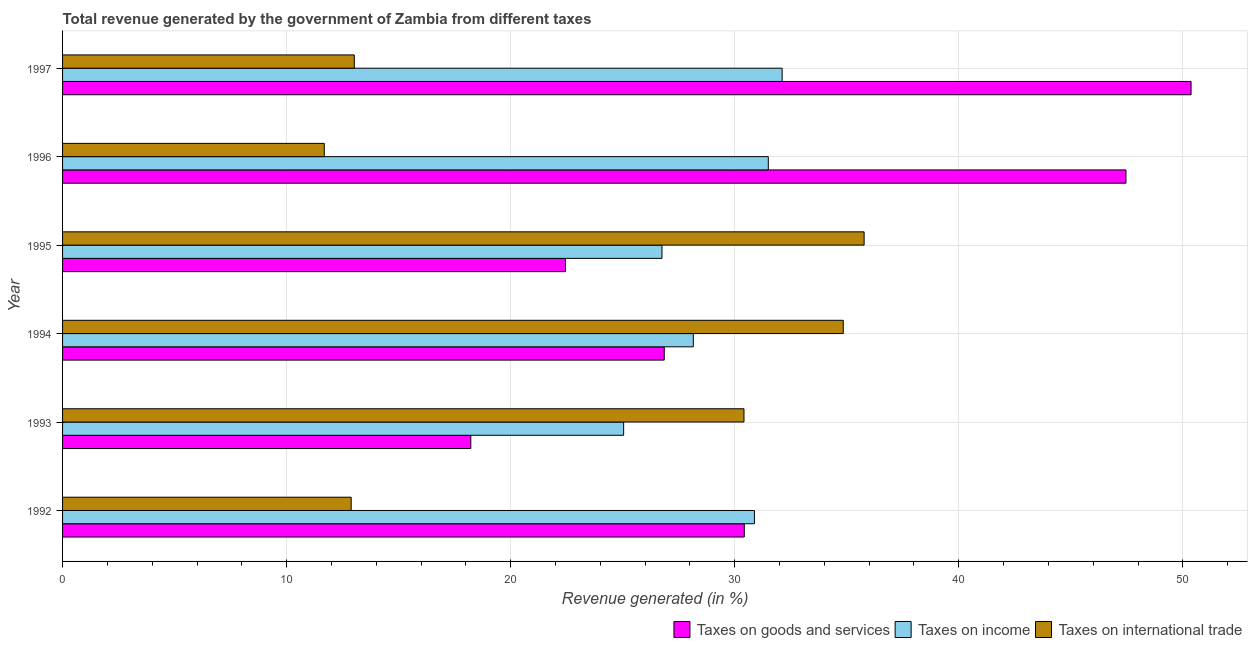In how many cases, is the number of bars for a given year not equal to the number of legend labels?
Your response must be concise. 0. What is the percentage of revenue generated by taxes on income in 1992?
Ensure brevity in your answer.  30.88. Across all years, what is the maximum percentage of revenue generated by taxes on income?
Give a very brief answer. 32.12. Across all years, what is the minimum percentage of revenue generated by taxes on income?
Ensure brevity in your answer.  25.04. In which year was the percentage of revenue generated by tax on international trade maximum?
Your answer should be very brief. 1995. In which year was the percentage of revenue generated by taxes on goods and services minimum?
Keep it short and to the point. 1993. What is the total percentage of revenue generated by taxes on income in the graph?
Provide a short and direct response. 174.44. What is the difference between the percentage of revenue generated by tax on international trade in 1992 and that in 1996?
Provide a short and direct response. 1.2. What is the difference between the percentage of revenue generated by taxes on goods and services in 1992 and the percentage of revenue generated by taxes on income in 1997?
Provide a short and direct response. -1.69. What is the average percentage of revenue generated by taxes on goods and services per year?
Your answer should be compact. 32.63. In the year 1992, what is the difference between the percentage of revenue generated by taxes on income and percentage of revenue generated by taxes on goods and services?
Offer a very short reply. 0.45. What is the ratio of the percentage of revenue generated by tax on international trade in 1993 to that in 1997?
Your response must be concise. 2.34. Is the difference between the percentage of revenue generated by taxes on income in 1994 and 1995 greater than the difference between the percentage of revenue generated by tax on international trade in 1994 and 1995?
Provide a succinct answer. Yes. What is the difference between the highest and the second highest percentage of revenue generated by taxes on goods and services?
Give a very brief answer. 2.9. What is the difference between the highest and the lowest percentage of revenue generated by tax on international trade?
Make the answer very short. 24.09. Is the sum of the percentage of revenue generated by tax on international trade in 1993 and 1997 greater than the maximum percentage of revenue generated by taxes on income across all years?
Provide a short and direct response. Yes. What does the 1st bar from the top in 1996 represents?
Make the answer very short. Taxes on international trade. What does the 3rd bar from the bottom in 1994 represents?
Make the answer very short. Taxes on international trade. Is it the case that in every year, the sum of the percentage of revenue generated by taxes on goods and services and percentage of revenue generated by taxes on income is greater than the percentage of revenue generated by tax on international trade?
Offer a terse response. Yes. Are all the bars in the graph horizontal?
Provide a short and direct response. Yes. What is the difference between two consecutive major ticks on the X-axis?
Your answer should be compact. 10. Are the values on the major ticks of X-axis written in scientific E-notation?
Offer a terse response. No. Does the graph contain grids?
Your response must be concise. Yes. Where does the legend appear in the graph?
Offer a very short reply. Bottom right. How are the legend labels stacked?
Provide a succinct answer. Horizontal. What is the title of the graph?
Offer a very short reply. Total revenue generated by the government of Zambia from different taxes. What is the label or title of the X-axis?
Make the answer very short. Revenue generated (in %). What is the Revenue generated (in %) of Taxes on goods and services in 1992?
Keep it short and to the point. 30.43. What is the Revenue generated (in %) of Taxes on income in 1992?
Your answer should be very brief. 30.88. What is the Revenue generated (in %) in Taxes on international trade in 1992?
Your answer should be compact. 12.88. What is the Revenue generated (in %) in Taxes on goods and services in 1993?
Offer a very short reply. 18.22. What is the Revenue generated (in %) of Taxes on income in 1993?
Provide a short and direct response. 25.04. What is the Revenue generated (in %) in Taxes on international trade in 1993?
Provide a succinct answer. 30.41. What is the Revenue generated (in %) in Taxes on goods and services in 1994?
Keep it short and to the point. 26.86. What is the Revenue generated (in %) in Taxes on income in 1994?
Offer a very short reply. 28.15. What is the Revenue generated (in %) in Taxes on international trade in 1994?
Your answer should be compact. 34.84. What is the Revenue generated (in %) of Taxes on goods and services in 1995?
Your response must be concise. 22.45. What is the Revenue generated (in %) of Taxes on income in 1995?
Offer a very short reply. 26.75. What is the Revenue generated (in %) in Taxes on international trade in 1995?
Your answer should be very brief. 35.78. What is the Revenue generated (in %) in Taxes on goods and services in 1996?
Your answer should be very brief. 47.46. What is the Revenue generated (in %) of Taxes on income in 1996?
Offer a terse response. 31.5. What is the Revenue generated (in %) in Taxes on international trade in 1996?
Offer a very short reply. 11.68. What is the Revenue generated (in %) in Taxes on goods and services in 1997?
Give a very brief answer. 50.37. What is the Revenue generated (in %) in Taxes on income in 1997?
Your response must be concise. 32.12. What is the Revenue generated (in %) in Taxes on international trade in 1997?
Your answer should be very brief. 13.02. Across all years, what is the maximum Revenue generated (in %) in Taxes on goods and services?
Your response must be concise. 50.37. Across all years, what is the maximum Revenue generated (in %) of Taxes on income?
Offer a very short reply. 32.12. Across all years, what is the maximum Revenue generated (in %) of Taxes on international trade?
Offer a terse response. 35.78. Across all years, what is the minimum Revenue generated (in %) of Taxes on goods and services?
Your response must be concise. 18.22. Across all years, what is the minimum Revenue generated (in %) of Taxes on income?
Ensure brevity in your answer.  25.04. Across all years, what is the minimum Revenue generated (in %) in Taxes on international trade?
Ensure brevity in your answer.  11.68. What is the total Revenue generated (in %) in Taxes on goods and services in the graph?
Offer a very short reply. 195.78. What is the total Revenue generated (in %) of Taxes on income in the graph?
Offer a terse response. 174.44. What is the total Revenue generated (in %) in Taxes on international trade in the graph?
Your response must be concise. 138.62. What is the difference between the Revenue generated (in %) in Taxes on goods and services in 1992 and that in 1993?
Keep it short and to the point. 12.21. What is the difference between the Revenue generated (in %) of Taxes on income in 1992 and that in 1993?
Keep it short and to the point. 5.84. What is the difference between the Revenue generated (in %) of Taxes on international trade in 1992 and that in 1993?
Your answer should be compact. -17.53. What is the difference between the Revenue generated (in %) of Taxes on goods and services in 1992 and that in 1994?
Your answer should be compact. 3.57. What is the difference between the Revenue generated (in %) of Taxes on income in 1992 and that in 1994?
Make the answer very short. 2.73. What is the difference between the Revenue generated (in %) in Taxes on international trade in 1992 and that in 1994?
Your response must be concise. -21.96. What is the difference between the Revenue generated (in %) in Taxes on goods and services in 1992 and that in 1995?
Offer a terse response. 7.98. What is the difference between the Revenue generated (in %) of Taxes on income in 1992 and that in 1995?
Ensure brevity in your answer.  4.13. What is the difference between the Revenue generated (in %) of Taxes on international trade in 1992 and that in 1995?
Your answer should be very brief. -22.89. What is the difference between the Revenue generated (in %) of Taxes on goods and services in 1992 and that in 1996?
Offer a very short reply. -17.04. What is the difference between the Revenue generated (in %) in Taxes on income in 1992 and that in 1996?
Your answer should be very brief. -0.62. What is the difference between the Revenue generated (in %) in Taxes on international trade in 1992 and that in 1996?
Offer a very short reply. 1.2. What is the difference between the Revenue generated (in %) of Taxes on goods and services in 1992 and that in 1997?
Give a very brief answer. -19.94. What is the difference between the Revenue generated (in %) of Taxes on income in 1992 and that in 1997?
Provide a short and direct response. -1.24. What is the difference between the Revenue generated (in %) of Taxes on international trade in 1992 and that in 1997?
Your answer should be compact. -0.14. What is the difference between the Revenue generated (in %) in Taxes on goods and services in 1993 and that in 1994?
Your response must be concise. -8.63. What is the difference between the Revenue generated (in %) in Taxes on income in 1993 and that in 1994?
Your response must be concise. -3.11. What is the difference between the Revenue generated (in %) of Taxes on international trade in 1993 and that in 1994?
Your answer should be compact. -4.43. What is the difference between the Revenue generated (in %) in Taxes on goods and services in 1993 and that in 1995?
Keep it short and to the point. -4.23. What is the difference between the Revenue generated (in %) of Taxes on income in 1993 and that in 1995?
Offer a terse response. -1.71. What is the difference between the Revenue generated (in %) of Taxes on international trade in 1993 and that in 1995?
Provide a short and direct response. -5.36. What is the difference between the Revenue generated (in %) in Taxes on goods and services in 1993 and that in 1996?
Provide a short and direct response. -29.24. What is the difference between the Revenue generated (in %) of Taxes on income in 1993 and that in 1996?
Make the answer very short. -6.46. What is the difference between the Revenue generated (in %) in Taxes on international trade in 1993 and that in 1996?
Your response must be concise. 18.73. What is the difference between the Revenue generated (in %) in Taxes on goods and services in 1993 and that in 1997?
Your response must be concise. -32.15. What is the difference between the Revenue generated (in %) in Taxes on income in 1993 and that in 1997?
Give a very brief answer. -7.07. What is the difference between the Revenue generated (in %) in Taxes on international trade in 1993 and that in 1997?
Give a very brief answer. 17.39. What is the difference between the Revenue generated (in %) of Taxes on goods and services in 1994 and that in 1995?
Keep it short and to the point. 4.41. What is the difference between the Revenue generated (in %) in Taxes on income in 1994 and that in 1995?
Offer a very short reply. 1.4. What is the difference between the Revenue generated (in %) of Taxes on international trade in 1994 and that in 1995?
Give a very brief answer. -0.93. What is the difference between the Revenue generated (in %) in Taxes on goods and services in 1994 and that in 1996?
Your answer should be compact. -20.61. What is the difference between the Revenue generated (in %) of Taxes on income in 1994 and that in 1996?
Offer a very short reply. -3.35. What is the difference between the Revenue generated (in %) in Taxes on international trade in 1994 and that in 1996?
Your answer should be very brief. 23.16. What is the difference between the Revenue generated (in %) of Taxes on goods and services in 1994 and that in 1997?
Provide a short and direct response. -23.51. What is the difference between the Revenue generated (in %) of Taxes on income in 1994 and that in 1997?
Make the answer very short. -3.96. What is the difference between the Revenue generated (in %) of Taxes on international trade in 1994 and that in 1997?
Provide a succinct answer. 21.82. What is the difference between the Revenue generated (in %) in Taxes on goods and services in 1995 and that in 1996?
Offer a very short reply. -25.01. What is the difference between the Revenue generated (in %) in Taxes on income in 1995 and that in 1996?
Offer a terse response. -4.75. What is the difference between the Revenue generated (in %) in Taxes on international trade in 1995 and that in 1996?
Your response must be concise. 24.09. What is the difference between the Revenue generated (in %) in Taxes on goods and services in 1995 and that in 1997?
Your response must be concise. -27.92. What is the difference between the Revenue generated (in %) in Taxes on income in 1995 and that in 1997?
Keep it short and to the point. -5.36. What is the difference between the Revenue generated (in %) in Taxes on international trade in 1995 and that in 1997?
Provide a short and direct response. 22.75. What is the difference between the Revenue generated (in %) of Taxes on goods and services in 1996 and that in 1997?
Ensure brevity in your answer.  -2.91. What is the difference between the Revenue generated (in %) in Taxes on income in 1996 and that in 1997?
Ensure brevity in your answer.  -0.62. What is the difference between the Revenue generated (in %) of Taxes on international trade in 1996 and that in 1997?
Your response must be concise. -1.34. What is the difference between the Revenue generated (in %) of Taxes on goods and services in 1992 and the Revenue generated (in %) of Taxes on income in 1993?
Your answer should be compact. 5.39. What is the difference between the Revenue generated (in %) of Taxes on goods and services in 1992 and the Revenue generated (in %) of Taxes on international trade in 1993?
Your answer should be compact. 0.01. What is the difference between the Revenue generated (in %) of Taxes on income in 1992 and the Revenue generated (in %) of Taxes on international trade in 1993?
Ensure brevity in your answer.  0.47. What is the difference between the Revenue generated (in %) in Taxes on goods and services in 1992 and the Revenue generated (in %) in Taxes on income in 1994?
Your answer should be compact. 2.28. What is the difference between the Revenue generated (in %) of Taxes on goods and services in 1992 and the Revenue generated (in %) of Taxes on international trade in 1994?
Provide a succinct answer. -4.42. What is the difference between the Revenue generated (in %) of Taxes on income in 1992 and the Revenue generated (in %) of Taxes on international trade in 1994?
Provide a short and direct response. -3.96. What is the difference between the Revenue generated (in %) of Taxes on goods and services in 1992 and the Revenue generated (in %) of Taxes on income in 1995?
Offer a terse response. 3.67. What is the difference between the Revenue generated (in %) of Taxes on goods and services in 1992 and the Revenue generated (in %) of Taxes on international trade in 1995?
Provide a short and direct response. -5.35. What is the difference between the Revenue generated (in %) of Taxes on income in 1992 and the Revenue generated (in %) of Taxes on international trade in 1995?
Your response must be concise. -4.9. What is the difference between the Revenue generated (in %) in Taxes on goods and services in 1992 and the Revenue generated (in %) in Taxes on income in 1996?
Your response must be concise. -1.07. What is the difference between the Revenue generated (in %) of Taxes on goods and services in 1992 and the Revenue generated (in %) of Taxes on international trade in 1996?
Your answer should be compact. 18.75. What is the difference between the Revenue generated (in %) of Taxes on income in 1992 and the Revenue generated (in %) of Taxes on international trade in 1996?
Keep it short and to the point. 19.2. What is the difference between the Revenue generated (in %) of Taxes on goods and services in 1992 and the Revenue generated (in %) of Taxes on income in 1997?
Your answer should be compact. -1.69. What is the difference between the Revenue generated (in %) in Taxes on goods and services in 1992 and the Revenue generated (in %) in Taxes on international trade in 1997?
Your response must be concise. 17.41. What is the difference between the Revenue generated (in %) in Taxes on income in 1992 and the Revenue generated (in %) in Taxes on international trade in 1997?
Ensure brevity in your answer.  17.86. What is the difference between the Revenue generated (in %) of Taxes on goods and services in 1993 and the Revenue generated (in %) of Taxes on income in 1994?
Your answer should be compact. -9.93. What is the difference between the Revenue generated (in %) in Taxes on goods and services in 1993 and the Revenue generated (in %) in Taxes on international trade in 1994?
Offer a terse response. -16.62. What is the difference between the Revenue generated (in %) of Taxes on income in 1993 and the Revenue generated (in %) of Taxes on international trade in 1994?
Your answer should be compact. -9.8. What is the difference between the Revenue generated (in %) of Taxes on goods and services in 1993 and the Revenue generated (in %) of Taxes on income in 1995?
Offer a terse response. -8.53. What is the difference between the Revenue generated (in %) of Taxes on goods and services in 1993 and the Revenue generated (in %) of Taxes on international trade in 1995?
Provide a succinct answer. -17.55. What is the difference between the Revenue generated (in %) of Taxes on income in 1993 and the Revenue generated (in %) of Taxes on international trade in 1995?
Ensure brevity in your answer.  -10.73. What is the difference between the Revenue generated (in %) of Taxes on goods and services in 1993 and the Revenue generated (in %) of Taxes on income in 1996?
Your answer should be compact. -13.28. What is the difference between the Revenue generated (in %) in Taxes on goods and services in 1993 and the Revenue generated (in %) in Taxes on international trade in 1996?
Make the answer very short. 6.54. What is the difference between the Revenue generated (in %) in Taxes on income in 1993 and the Revenue generated (in %) in Taxes on international trade in 1996?
Provide a short and direct response. 13.36. What is the difference between the Revenue generated (in %) in Taxes on goods and services in 1993 and the Revenue generated (in %) in Taxes on income in 1997?
Your response must be concise. -13.89. What is the difference between the Revenue generated (in %) in Taxes on goods and services in 1993 and the Revenue generated (in %) in Taxes on international trade in 1997?
Provide a succinct answer. 5.2. What is the difference between the Revenue generated (in %) in Taxes on income in 1993 and the Revenue generated (in %) in Taxes on international trade in 1997?
Ensure brevity in your answer.  12.02. What is the difference between the Revenue generated (in %) in Taxes on goods and services in 1994 and the Revenue generated (in %) in Taxes on income in 1995?
Your answer should be very brief. 0.1. What is the difference between the Revenue generated (in %) of Taxes on goods and services in 1994 and the Revenue generated (in %) of Taxes on international trade in 1995?
Provide a succinct answer. -8.92. What is the difference between the Revenue generated (in %) in Taxes on income in 1994 and the Revenue generated (in %) in Taxes on international trade in 1995?
Your response must be concise. -7.62. What is the difference between the Revenue generated (in %) of Taxes on goods and services in 1994 and the Revenue generated (in %) of Taxes on income in 1996?
Ensure brevity in your answer.  -4.64. What is the difference between the Revenue generated (in %) of Taxes on goods and services in 1994 and the Revenue generated (in %) of Taxes on international trade in 1996?
Keep it short and to the point. 15.17. What is the difference between the Revenue generated (in %) in Taxes on income in 1994 and the Revenue generated (in %) in Taxes on international trade in 1996?
Your answer should be compact. 16.47. What is the difference between the Revenue generated (in %) in Taxes on goods and services in 1994 and the Revenue generated (in %) in Taxes on income in 1997?
Ensure brevity in your answer.  -5.26. What is the difference between the Revenue generated (in %) in Taxes on goods and services in 1994 and the Revenue generated (in %) in Taxes on international trade in 1997?
Your response must be concise. 13.83. What is the difference between the Revenue generated (in %) in Taxes on income in 1994 and the Revenue generated (in %) in Taxes on international trade in 1997?
Offer a terse response. 15.13. What is the difference between the Revenue generated (in %) of Taxes on goods and services in 1995 and the Revenue generated (in %) of Taxes on income in 1996?
Keep it short and to the point. -9.05. What is the difference between the Revenue generated (in %) of Taxes on goods and services in 1995 and the Revenue generated (in %) of Taxes on international trade in 1996?
Keep it short and to the point. 10.77. What is the difference between the Revenue generated (in %) of Taxes on income in 1995 and the Revenue generated (in %) of Taxes on international trade in 1996?
Your answer should be compact. 15.07. What is the difference between the Revenue generated (in %) in Taxes on goods and services in 1995 and the Revenue generated (in %) in Taxes on income in 1997?
Your response must be concise. -9.67. What is the difference between the Revenue generated (in %) of Taxes on goods and services in 1995 and the Revenue generated (in %) of Taxes on international trade in 1997?
Your response must be concise. 9.43. What is the difference between the Revenue generated (in %) of Taxes on income in 1995 and the Revenue generated (in %) of Taxes on international trade in 1997?
Offer a terse response. 13.73. What is the difference between the Revenue generated (in %) in Taxes on goods and services in 1996 and the Revenue generated (in %) in Taxes on income in 1997?
Provide a short and direct response. 15.35. What is the difference between the Revenue generated (in %) of Taxes on goods and services in 1996 and the Revenue generated (in %) of Taxes on international trade in 1997?
Ensure brevity in your answer.  34.44. What is the difference between the Revenue generated (in %) of Taxes on income in 1996 and the Revenue generated (in %) of Taxes on international trade in 1997?
Ensure brevity in your answer.  18.48. What is the average Revenue generated (in %) of Taxes on goods and services per year?
Your answer should be compact. 32.63. What is the average Revenue generated (in %) of Taxes on income per year?
Make the answer very short. 29.07. What is the average Revenue generated (in %) of Taxes on international trade per year?
Your response must be concise. 23.1. In the year 1992, what is the difference between the Revenue generated (in %) of Taxes on goods and services and Revenue generated (in %) of Taxes on income?
Your answer should be compact. -0.45. In the year 1992, what is the difference between the Revenue generated (in %) of Taxes on goods and services and Revenue generated (in %) of Taxes on international trade?
Ensure brevity in your answer.  17.55. In the year 1992, what is the difference between the Revenue generated (in %) of Taxes on income and Revenue generated (in %) of Taxes on international trade?
Your response must be concise. 18. In the year 1993, what is the difference between the Revenue generated (in %) of Taxes on goods and services and Revenue generated (in %) of Taxes on income?
Ensure brevity in your answer.  -6.82. In the year 1993, what is the difference between the Revenue generated (in %) of Taxes on goods and services and Revenue generated (in %) of Taxes on international trade?
Keep it short and to the point. -12.19. In the year 1993, what is the difference between the Revenue generated (in %) in Taxes on income and Revenue generated (in %) in Taxes on international trade?
Provide a short and direct response. -5.37. In the year 1994, what is the difference between the Revenue generated (in %) of Taxes on goods and services and Revenue generated (in %) of Taxes on income?
Provide a short and direct response. -1.3. In the year 1994, what is the difference between the Revenue generated (in %) in Taxes on goods and services and Revenue generated (in %) in Taxes on international trade?
Provide a short and direct response. -7.99. In the year 1994, what is the difference between the Revenue generated (in %) in Taxes on income and Revenue generated (in %) in Taxes on international trade?
Offer a terse response. -6.69. In the year 1995, what is the difference between the Revenue generated (in %) in Taxes on goods and services and Revenue generated (in %) in Taxes on income?
Ensure brevity in your answer.  -4.3. In the year 1995, what is the difference between the Revenue generated (in %) of Taxes on goods and services and Revenue generated (in %) of Taxes on international trade?
Give a very brief answer. -13.33. In the year 1995, what is the difference between the Revenue generated (in %) in Taxes on income and Revenue generated (in %) in Taxes on international trade?
Your answer should be compact. -9.02. In the year 1996, what is the difference between the Revenue generated (in %) of Taxes on goods and services and Revenue generated (in %) of Taxes on income?
Give a very brief answer. 15.96. In the year 1996, what is the difference between the Revenue generated (in %) in Taxes on goods and services and Revenue generated (in %) in Taxes on international trade?
Keep it short and to the point. 35.78. In the year 1996, what is the difference between the Revenue generated (in %) of Taxes on income and Revenue generated (in %) of Taxes on international trade?
Your answer should be compact. 19.82. In the year 1997, what is the difference between the Revenue generated (in %) of Taxes on goods and services and Revenue generated (in %) of Taxes on income?
Ensure brevity in your answer.  18.25. In the year 1997, what is the difference between the Revenue generated (in %) of Taxes on goods and services and Revenue generated (in %) of Taxes on international trade?
Your response must be concise. 37.35. In the year 1997, what is the difference between the Revenue generated (in %) of Taxes on income and Revenue generated (in %) of Taxes on international trade?
Provide a short and direct response. 19.09. What is the ratio of the Revenue generated (in %) of Taxes on goods and services in 1992 to that in 1993?
Your answer should be very brief. 1.67. What is the ratio of the Revenue generated (in %) of Taxes on income in 1992 to that in 1993?
Offer a very short reply. 1.23. What is the ratio of the Revenue generated (in %) in Taxes on international trade in 1992 to that in 1993?
Give a very brief answer. 0.42. What is the ratio of the Revenue generated (in %) of Taxes on goods and services in 1992 to that in 1994?
Your response must be concise. 1.13. What is the ratio of the Revenue generated (in %) in Taxes on income in 1992 to that in 1994?
Provide a succinct answer. 1.1. What is the ratio of the Revenue generated (in %) of Taxes on international trade in 1992 to that in 1994?
Your response must be concise. 0.37. What is the ratio of the Revenue generated (in %) in Taxes on goods and services in 1992 to that in 1995?
Offer a very short reply. 1.36. What is the ratio of the Revenue generated (in %) of Taxes on income in 1992 to that in 1995?
Provide a succinct answer. 1.15. What is the ratio of the Revenue generated (in %) of Taxes on international trade in 1992 to that in 1995?
Ensure brevity in your answer.  0.36. What is the ratio of the Revenue generated (in %) in Taxes on goods and services in 1992 to that in 1996?
Keep it short and to the point. 0.64. What is the ratio of the Revenue generated (in %) of Taxes on income in 1992 to that in 1996?
Make the answer very short. 0.98. What is the ratio of the Revenue generated (in %) of Taxes on international trade in 1992 to that in 1996?
Offer a very short reply. 1.1. What is the ratio of the Revenue generated (in %) of Taxes on goods and services in 1992 to that in 1997?
Provide a succinct answer. 0.6. What is the ratio of the Revenue generated (in %) of Taxes on income in 1992 to that in 1997?
Give a very brief answer. 0.96. What is the ratio of the Revenue generated (in %) in Taxes on international trade in 1992 to that in 1997?
Make the answer very short. 0.99. What is the ratio of the Revenue generated (in %) in Taxes on goods and services in 1993 to that in 1994?
Make the answer very short. 0.68. What is the ratio of the Revenue generated (in %) in Taxes on income in 1993 to that in 1994?
Ensure brevity in your answer.  0.89. What is the ratio of the Revenue generated (in %) of Taxes on international trade in 1993 to that in 1994?
Your response must be concise. 0.87. What is the ratio of the Revenue generated (in %) of Taxes on goods and services in 1993 to that in 1995?
Your answer should be very brief. 0.81. What is the ratio of the Revenue generated (in %) in Taxes on income in 1993 to that in 1995?
Make the answer very short. 0.94. What is the ratio of the Revenue generated (in %) of Taxes on international trade in 1993 to that in 1995?
Give a very brief answer. 0.85. What is the ratio of the Revenue generated (in %) of Taxes on goods and services in 1993 to that in 1996?
Keep it short and to the point. 0.38. What is the ratio of the Revenue generated (in %) of Taxes on income in 1993 to that in 1996?
Your answer should be compact. 0.8. What is the ratio of the Revenue generated (in %) of Taxes on international trade in 1993 to that in 1996?
Make the answer very short. 2.6. What is the ratio of the Revenue generated (in %) of Taxes on goods and services in 1993 to that in 1997?
Provide a succinct answer. 0.36. What is the ratio of the Revenue generated (in %) in Taxes on income in 1993 to that in 1997?
Offer a very short reply. 0.78. What is the ratio of the Revenue generated (in %) of Taxes on international trade in 1993 to that in 1997?
Make the answer very short. 2.34. What is the ratio of the Revenue generated (in %) in Taxes on goods and services in 1994 to that in 1995?
Your answer should be compact. 1.2. What is the ratio of the Revenue generated (in %) of Taxes on income in 1994 to that in 1995?
Offer a terse response. 1.05. What is the ratio of the Revenue generated (in %) in Taxes on international trade in 1994 to that in 1995?
Your response must be concise. 0.97. What is the ratio of the Revenue generated (in %) of Taxes on goods and services in 1994 to that in 1996?
Make the answer very short. 0.57. What is the ratio of the Revenue generated (in %) in Taxes on income in 1994 to that in 1996?
Make the answer very short. 0.89. What is the ratio of the Revenue generated (in %) in Taxes on international trade in 1994 to that in 1996?
Provide a succinct answer. 2.98. What is the ratio of the Revenue generated (in %) of Taxes on goods and services in 1994 to that in 1997?
Offer a very short reply. 0.53. What is the ratio of the Revenue generated (in %) of Taxes on income in 1994 to that in 1997?
Offer a terse response. 0.88. What is the ratio of the Revenue generated (in %) in Taxes on international trade in 1994 to that in 1997?
Keep it short and to the point. 2.68. What is the ratio of the Revenue generated (in %) of Taxes on goods and services in 1995 to that in 1996?
Ensure brevity in your answer.  0.47. What is the ratio of the Revenue generated (in %) in Taxes on income in 1995 to that in 1996?
Give a very brief answer. 0.85. What is the ratio of the Revenue generated (in %) of Taxes on international trade in 1995 to that in 1996?
Offer a very short reply. 3.06. What is the ratio of the Revenue generated (in %) in Taxes on goods and services in 1995 to that in 1997?
Your answer should be very brief. 0.45. What is the ratio of the Revenue generated (in %) of Taxes on income in 1995 to that in 1997?
Ensure brevity in your answer.  0.83. What is the ratio of the Revenue generated (in %) in Taxes on international trade in 1995 to that in 1997?
Ensure brevity in your answer.  2.75. What is the ratio of the Revenue generated (in %) of Taxes on goods and services in 1996 to that in 1997?
Provide a short and direct response. 0.94. What is the ratio of the Revenue generated (in %) of Taxes on income in 1996 to that in 1997?
Provide a short and direct response. 0.98. What is the ratio of the Revenue generated (in %) in Taxes on international trade in 1996 to that in 1997?
Ensure brevity in your answer.  0.9. What is the difference between the highest and the second highest Revenue generated (in %) of Taxes on goods and services?
Provide a short and direct response. 2.91. What is the difference between the highest and the second highest Revenue generated (in %) in Taxes on income?
Your response must be concise. 0.62. What is the difference between the highest and the second highest Revenue generated (in %) of Taxes on international trade?
Your answer should be very brief. 0.93. What is the difference between the highest and the lowest Revenue generated (in %) of Taxes on goods and services?
Offer a terse response. 32.15. What is the difference between the highest and the lowest Revenue generated (in %) of Taxes on income?
Provide a succinct answer. 7.07. What is the difference between the highest and the lowest Revenue generated (in %) of Taxes on international trade?
Offer a very short reply. 24.09. 